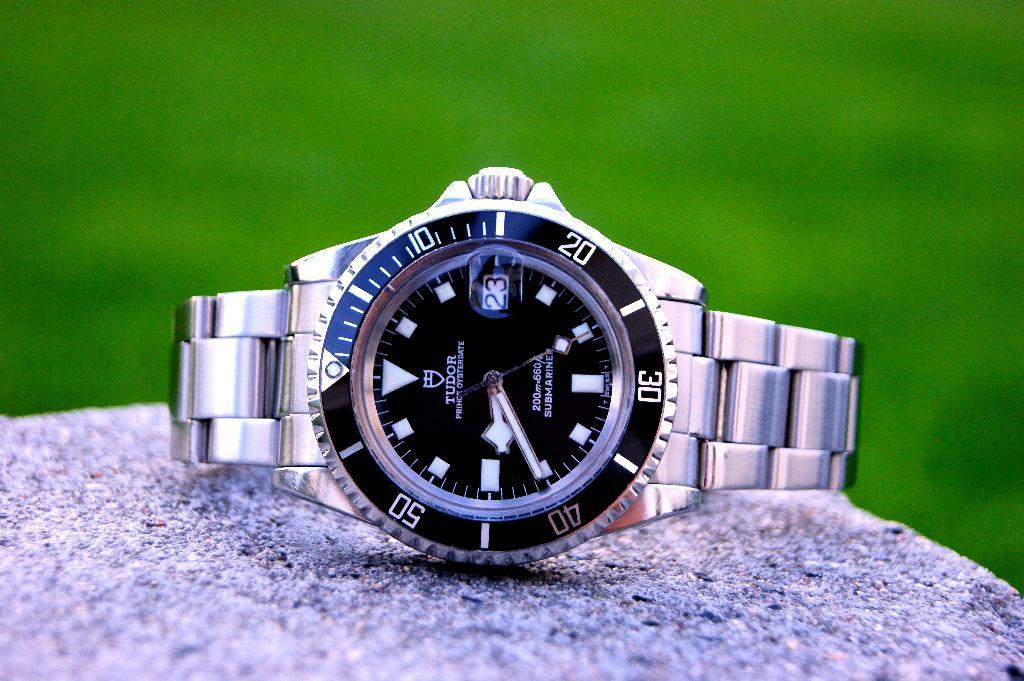<image>
Relay a brief, clear account of the picture shown. The Tudor watch shows the time and the date. 